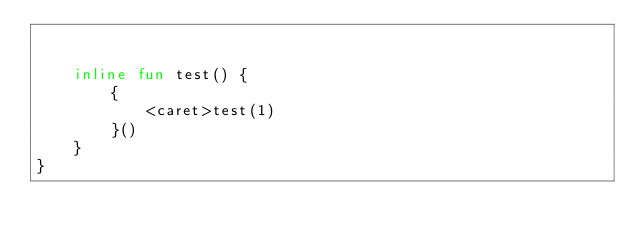<code> <loc_0><loc_0><loc_500><loc_500><_Kotlin_>

    inline fun test() {
        {
            <caret>test(1)
        }()
    }
}</code> 